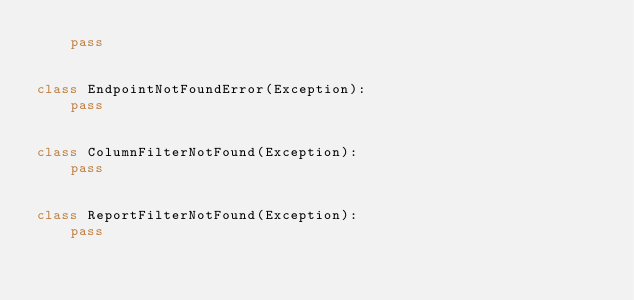<code> <loc_0><loc_0><loc_500><loc_500><_Python_>    pass


class EndpointNotFoundError(Exception):
    pass


class ColumnFilterNotFound(Exception):
    pass


class ReportFilterNotFound(Exception):
    pass
</code> 